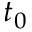Convert formula to latex. <formula><loc_0><loc_0><loc_500><loc_500>t _ { 0 }</formula> 